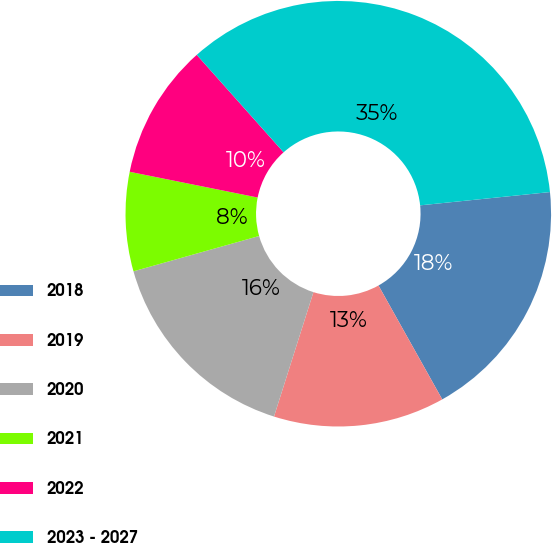<chart> <loc_0><loc_0><loc_500><loc_500><pie_chart><fcel>2018<fcel>2019<fcel>2020<fcel>2021<fcel>2022<fcel>2023 - 2027<nl><fcel>18.5%<fcel>13.01%<fcel>15.75%<fcel>7.52%<fcel>10.26%<fcel>34.96%<nl></chart> 